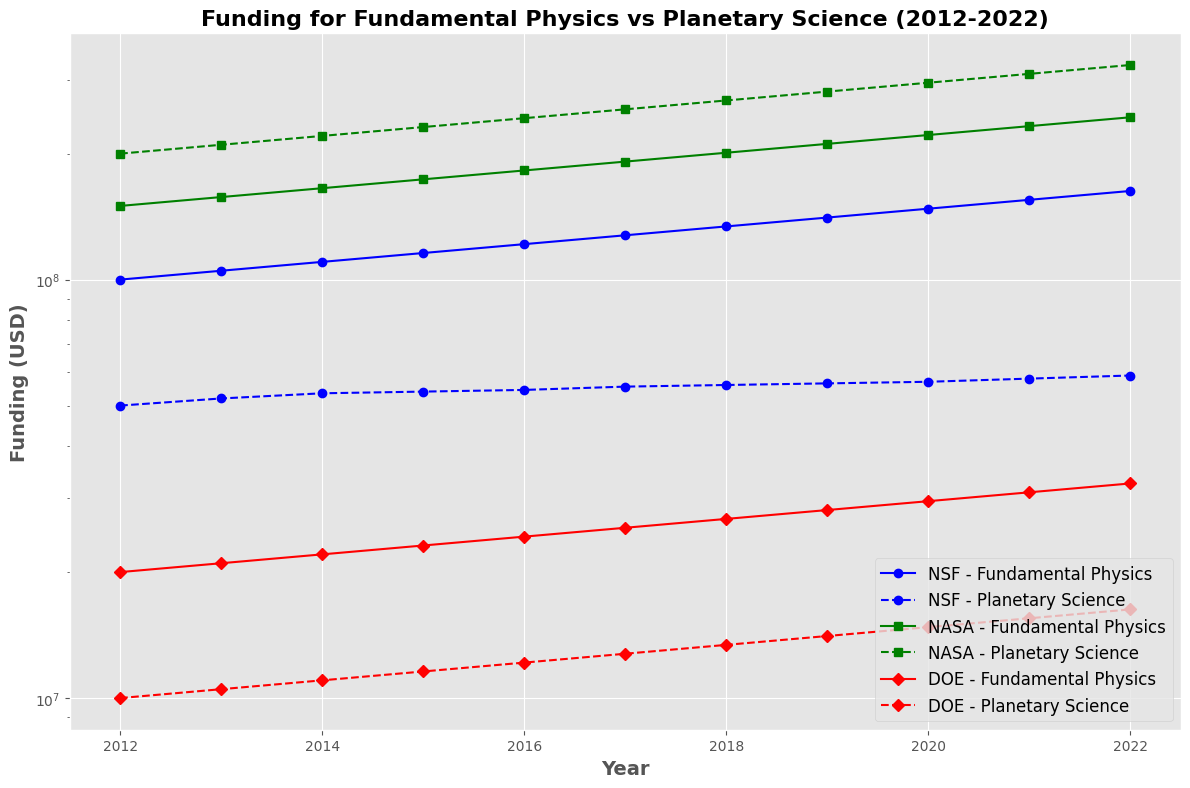How does the funding for NSF's Fundamental Physics compare to Planetary Science in 2022? From the figure, observe the points marked for 2022 under NSF for both Fundamental Physics and Planetary Science. Notice that the Fundamental Physics funding appears higher.
Answer: NSF's Fundamental Physics funding is higher in 2022 What is the overall trend in funding for NASA's Planetary Science over the decade? Looking at the plot for NASA's Planetary Science, note that the line consistently increases from 2012 to 2022, indicating a continuous rise in funding.
Answer: Continuous increase Which agency allocated more funding to Fundamental Physics in 2020, NASA or NSF? Compare the data points for 2020 from NASA and NSF under Fundamental Physics, noting that NASA's point is higher than NSF's for that year.
Answer: NASA What is the ratio of NASA's Planetary Science funding to DOE's Fundamental Physics funding in 2022? Identify the 2022 data points for NASA's Planetary Science and DOE's Fundamental Physics. Divide NASA's Planetary Science funding by DOE's Fundamental Physics funding. Calculation: 325,779,925 / 32,577,993 = 10.
Answer: 10 Across all agencies, which discipline (Fundamental Physics or Planetary Science) has the sharper rise in NSF funding over the decade? Observe the slopes of the lines for both disciplines under NSF from 2012 to 2022. The line for Fundamental Physics is steeper than the line for Planetary Science, indicating a sharper rise.
Answer: Fundamental Physics Is there any year where DOE allocated the same amount of funding to both Fundamental Physics and Planetary Science? Check the points for DOE across the timelines for any overlap. Note that each year shows a distinct difference, with no equal funding observed.
Answer: No Between 2014 and 2019, what is the difference in the incremental percentage increase in funding for NASA's Fundamental Physics versus Planetary Science? Calculate the percentage increase for both disciplines from 2014 to 2019 and then find the difference between the two percentages. Fundamental Physics: ((211,065,062 - 165,375,000) / 165,375,000) x 100 = 27.57%, Planetary Science: ((281,420,085 - 220,500,000) / 220,500,000) x 100 = 27.63%. Difference = 27.63% - 27.57% = 0.06%.
Answer: 0.06% What is the average annual funding for DOE's Planetary Science from 2012 to 2022? Sum the annual funding values for DOE's Planetary Science from 2012 to 2022, then divide by 11 (number of years). Calculation: (10,000,000 + 10,500,000 + 11,025,000 + 11,576,250 + 12,155,063 + 12,762,816 + 13,400,956 + 14,071,004 + 14,774,554 + 15,513,282 + 16,288,946) / 11 = 12,452,534.
Answer: 12,452,534 By approximately how much did NSF's Fundamental Physics funding grow between 2012 and 2022? Subtract the 2012 funding value from the 2022 value for NSF's Fundamental Physics. Calculation: 162,889,461 - 100,000,000 = 62,889,461.
Answer: 62,889,461 Which discipline has higher funding variability in NSF: Fundamental Physics or Planetary Science? Compare the spread of values for both disciplines under NSF. Fundamental Physics has a larger range of funding variations compared to Planetary Science.
Answer: Fundamental Physics 